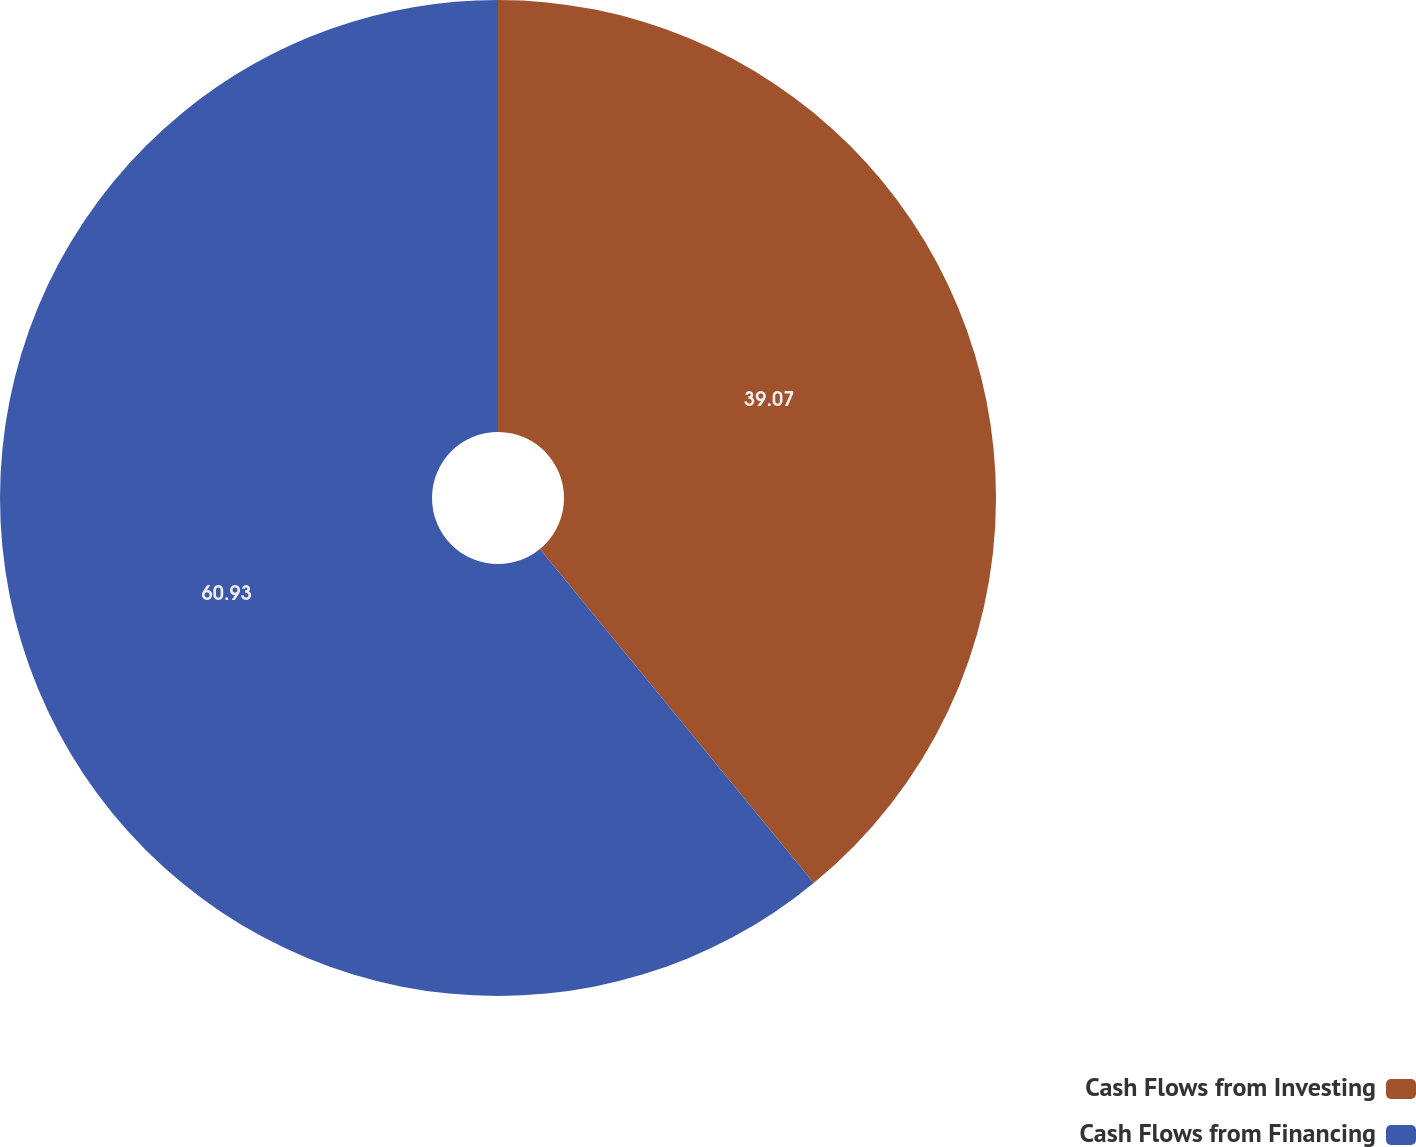<chart> <loc_0><loc_0><loc_500><loc_500><pie_chart><fcel>Cash Flows from Investing<fcel>Cash Flows from Financing<nl><fcel>39.07%<fcel>60.93%<nl></chart> 